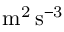<formula> <loc_0><loc_0><loc_500><loc_500>m ^ { 2 } \, s ^ { - 3 }</formula> 